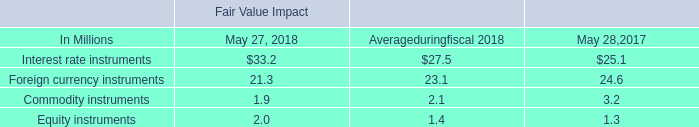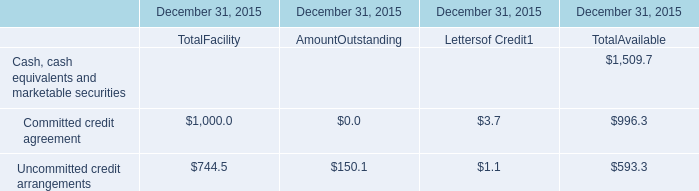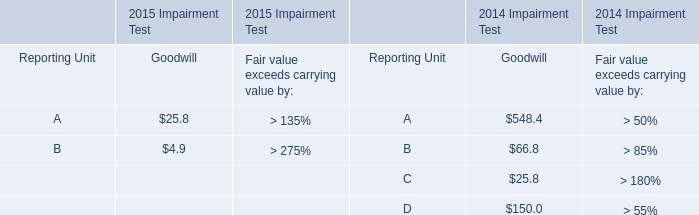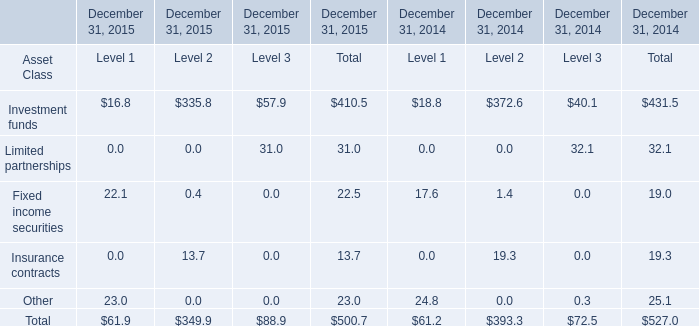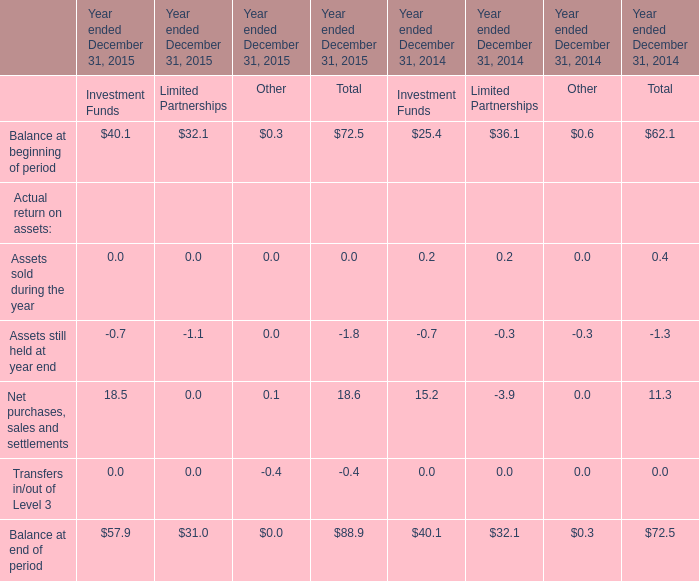What will Fixed income securities be like in 2016 if it develops with the same increasing rate as current? 
Computations: (22.5 * (1 + ((22.5 - 19) / 19)))
Answer: 26.64474. 